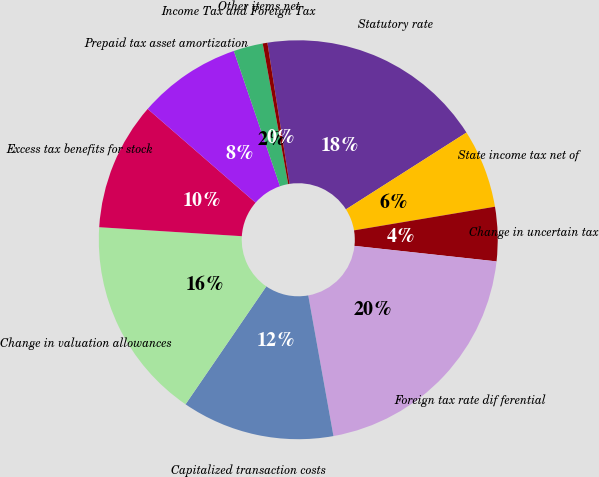<chart> <loc_0><loc_0><loc_500><loc_500><pie_chart><fcel>Statutory rate<fcel>State income tax net of<fcel>Change in uncertain tax<fcel>Foreign tax rate dif ferential<fcel>Capitalized transaction costs<fcel>Change in valuation allowances<fcel>Excess tax benefits for stock<fcel>Prepaid tax asset amortization<fcel>Income Tax and Foreign Tax<fcel>Other items net<nl><fcel>18.44%<fcel>6.38%<fcel>4.38%<fcel>20.44%<fcel>12.38%<fcel>16.44%<fcel>10.38%<fcel>8.38%<fcel>2.38%<fcel>0.38%<nl></chart> 